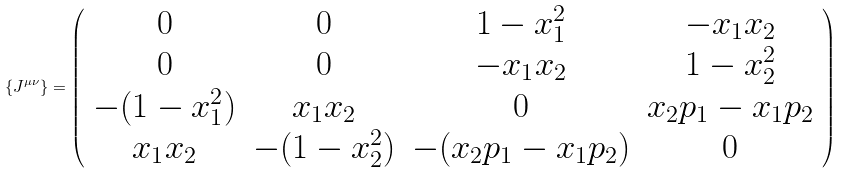<formula> <loc_0><loc_0><loc_500><loc_500>\{ J ^ { \mu \nu } \} = \left ( \begin{array} { c c c c } 0 & 0 & 1 - x _ { 1 } ^ { 2 } & - x _ { 1 } x _ { 2 } \\ 0 & 0 & - x _ { 1 } x _ { 2 } & 1 - x _ { 2 } ^ { 2 } \\ - ( 1 - x _ { 1 } ^ { 2 } ) & x _ { 1 } x _ { 2 } & 0 & x _ { 2 } p _ { 1 } - x _ { 1 } p _ { 2 } \\ x _ { 1 } x _ { 2 } & - ( 1 - x _ { 2 } ^ { 2 } ) & - ( x _ { 2 } p _ { 1 } - x _ { 1 } p _ { 2 } ) & 0 \end{array} \right )</formula> 